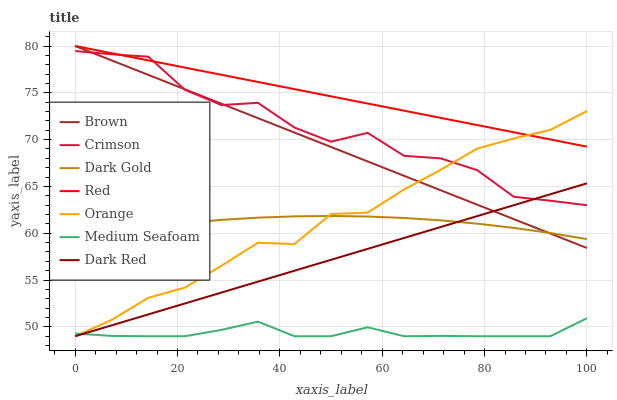Does Dark Gold have the minimum area under the curve?
Answer yes or no. No. Does Dark Gold have the maximum area under the curve?
Answer yes or no. No. Is Dark Gold the smoothest?
Answer yes or no. No. Is Dark Gold the roughest?
Answer yes or no. No. Does Dark Gold have the lowest value?
Answer yes or no. No. Does Dark Gold have the highest value?
Answer yes or no. No. Is Dark Gold less than Red?
Answer yes or no. Yes. Is Red greater than Dark Gold?
Answer yes or no. Yes. Does Dark Gold intersect Red?
Answer yes or no. No. 